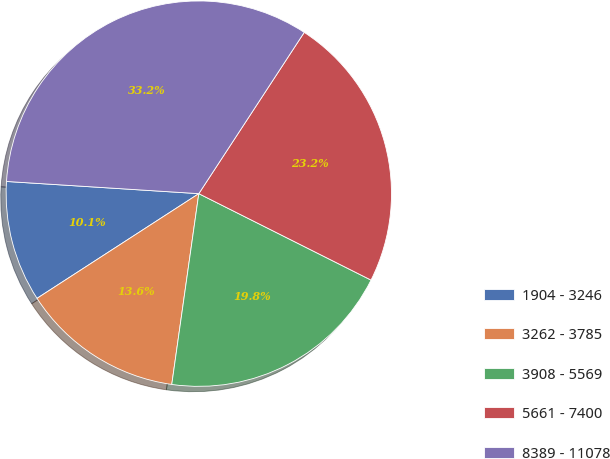<chart> <loc_0><loc_0><loc_500><loc_500><pie_chart><fcel>1904 - 3246<fcel>3262 - 3785<fcel>3908 - 5569<fcel>5661 - 7400<fcel>8389 - 11078<nl><fcel>10.15%<fcel>13.62%<fcel>19.84%<fcel>23.19%<fcel>33.21%<nl></chart> 